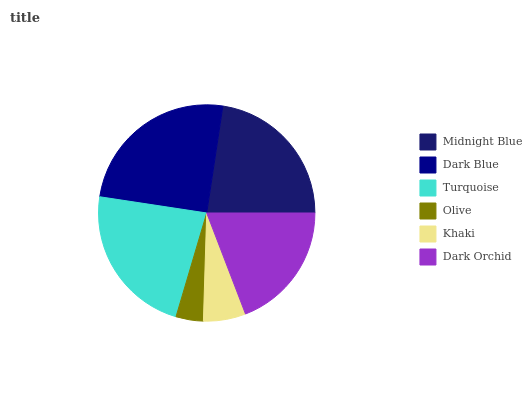Is Olive the minimum?
Answer yes or no. Yes. Is Dark Blue the maximum?
Answer yes or no. Yes. Is Turquoise the minimum?
Answer yes or no. No. Is Turquoise the maximum?
Answer yes or no. No. Is Dark Blue greater than Turquoise?
Answer yes or no. Yes. Is Turquoise less than Dark Blue?
Answer yes or no. Yes. Is Turquoise greater than Dark Blue?
Answer yes or no. No. Is Dark Blue less than Turquoise?
Answer yes or no. No. Is Midnight Blue the high median?
Answer yes or no. Yes. Is Dark Orchid the low median?
Answer yes or no. Yes. Is Olive the high median?
Answer yes or no. No. Is Olive the low median?
Answer yes or no. No. 